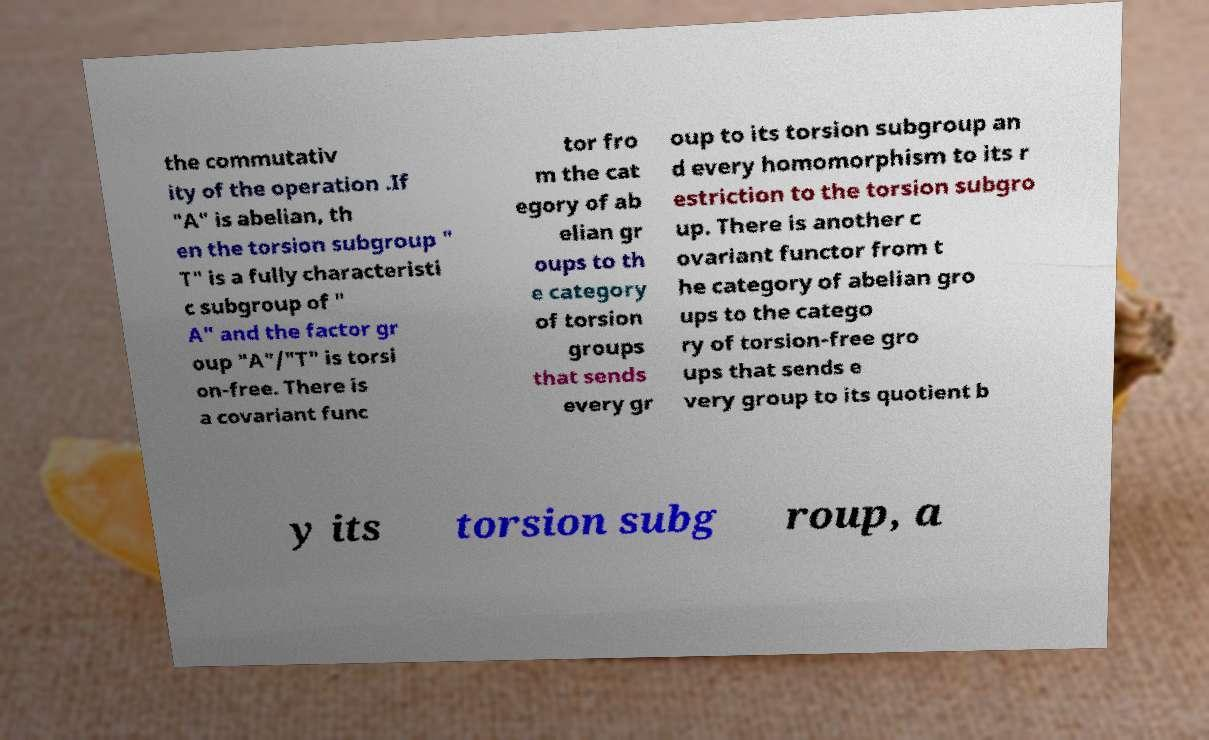What messages or text are displayed in this image? I need them in a readable, typed format. the commutativ ity of the operation .If "A" is abelian, th en the torsion subgroup " T" is a fully characteristi c subgroup of " A" and the factor gr oup "A"/"T" is torsi on-free. There is a covariant func tor fro m the cat egory of ab elian gr oups to th e category of torsion groups that sends every gr oup to its torsion subgroup an d every homomorphism to its r estriction to the torsion subgro up. There is another c ovariant functor from t he category of abelian gro ups to the catego ry of torsion-free gro ups that sends e very group to its quotient b y its torsion subg roup, a 